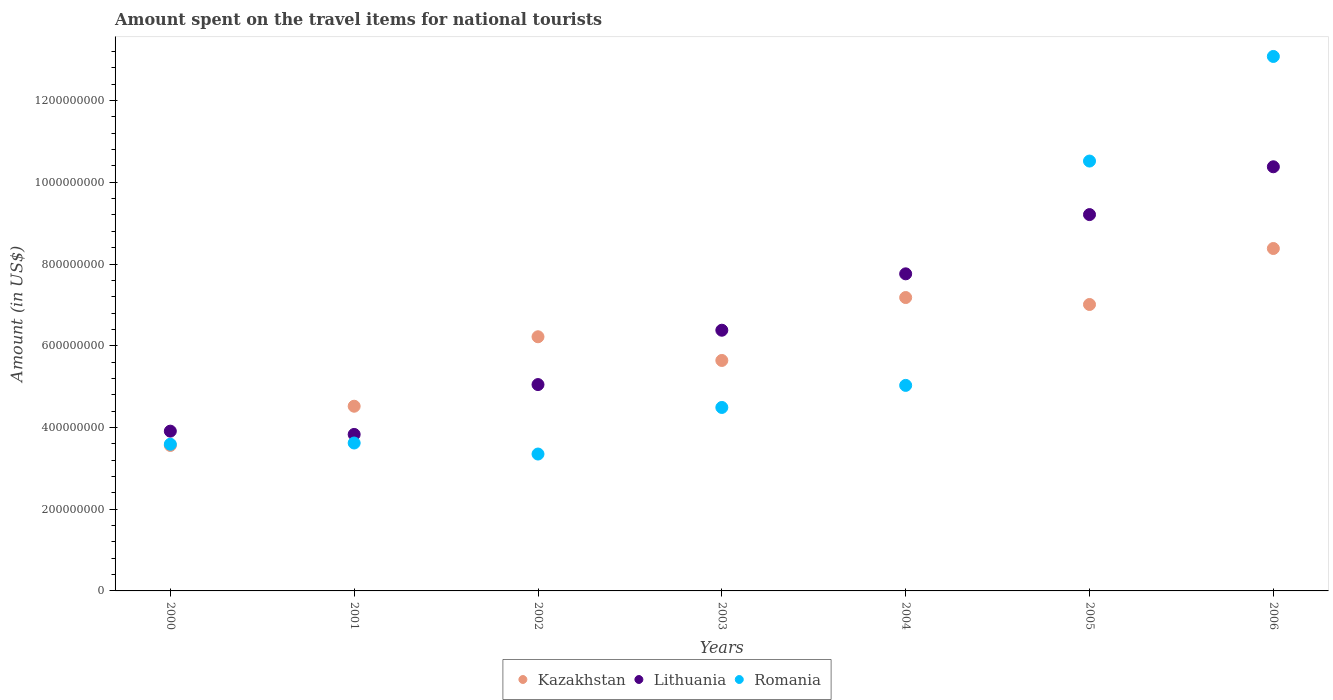How many different coloured dotlines are there?
Ensure brevity in your answer.  3. Is the number of dotlines equal to the number of legend labels?
Keep it short and to the point. Yes. What is the amount spent on the travel items for national tourists in Romania in 2001?
Keep it short and to the point. 3.62e+08. Across all years, what is the maximum amount spent on the travel items for national tourists in Kazakhstan?
Provide a short and direct response. 8.38e+08. Across all years, what is the minimum amount spent on the travel items for national tourists in Romania?
Ensure brevity in your answer.  3.35e+08. In which year was the amount spent on the travel items for national tourists in Lithuania maximum?
Provide a short and direct response. 2006. In which year was the amount spent on the travel items for national tourists in Kazakhstan minimum?
Provide a succinct answer. 2000. What is the total amount spent on the travel items for national tourists in Romania in the graph?
Give a very brief answer. 4.37e+09. What is the difference between the amount spent on the travel items for national tourists in Romania in 2000 and that in 2005?
Your response must be concise. -6.93e+08. What is the difference between the amount spent on the travel items for national tourists in Kazakhstan in 2000 and the amount spent on the travel items for national tourists in Romania in 2005?
Ensure brevity in your answer.  -6.96e+08. What is the average amount spent on the travel items for national tourists in Lithuania per year?
Keep it short and to the point. 6.65e+08. In the year 2003, what is the difference between the amount spent on the travel items for national tourists in Kazakhstan and amount spent on the travel items for national tourists in Lithuania?
Offer a very short reply. -7.40e+07. In how many years, is the amount spent on the travel items for national tourists in Kazakhstan greater than 960000000 US$?
Make the answer very short. 0. What is the ratio of the amount spent on the travel items for national tourists in Lithuania in 2004 to that in 2005?
Provide a succinct answer. 0.84. Is the difference between the amount spent on the travel items for national tourists in Kazakhstan in 2002 and 2004 greater than the difference between the amount spent on the travel items for national tourists in Lithuania in 2002 and 2004?
Your answer should be compact. Yes. What is the difference between the highest and the second highest amount spent on the travel items for national tourists in Kazakhstan?
Ensure brevity in your answer.  1.20e+08. What is the difference between the highest and the lowest amount spent on the travel items for national tourists in Romania?
Your answer should be compact. 9.73e+08. In how many years, is the amount spent on the travel items for national tourists in Romania greater than the average amount spent on the travel items for national tourists in Romania taken over all years?
Provide a succinct answer. 2. Is it the case that in every year, the sum of the amount spent on the travel items for national tourists in Romania and amount spent on the travel items for national tourists in Kazakhstan  is greater than the amount spent on the travel items for national tourists in Lithuania?
Offer a very short reply. Yes. Does the amount spent on the travel items for national tourists in Romania monotonically increase over the years?
Your answer should be very brief. No. How many dotlines are there?
Make the answer very short. 3. Where does the legend appear in the graph?
Ensure brevity in your answer.  Bottom center. What is the title of the graph?
Keep it short and to the point. Amount spent on the travel items for national tourists. What is the label or title of the Y-axis?
Your answer should be compact. Amount (in US$). What is the Amount (in US$) of Kazakhstan in 2000?
Make the answer very short. 3.56e+08. What is the Amount (in US$) in Lithuania in 2000?
Your answer should be very brief. 3.91e+08. What is the Amount (in US$) in Romania in 2000?
Ensure brevity in your answer.  3.59e+08. What is the Amount (in US$) of Kazakhstan in 2001?
Your answer should be very brief. 4.52e+08. What is the Amount (in US$) of Lithuania in 2001?
Make the answer very short. 3.83e+08. What is the Amount (in US$) in Romania in 2001?
Offer a terse response. 3.62e+08. What is the Amount (in US$) in Kazakhstan in 2002?
Your answer should be compact. 6.22e+08. What is the Amount (in US$) in Lithuania in 2002?
Your answer should be compact. 5.05e+08. What is the Amount (in US$) in Romania in 2002?
Offer a terse response. 3.35e+08. What is the Amount (in US$) of Kazakhstan in 2003?
Offer a very short reply. 5.64e+08. What is the Amount (in US$) of Lithuania in 2003?
Your response must be concise. 6.38e+08. What is the Amount (in US$) in Romania in 2003?
Make the answer very short. 4.49e+08. What is the Amount (in US$) in Kazakhstan in 2004?
Keep it short and to the point. 7.18e+08. What is the Amount (in US$) in Lithuania in 2004?
Ensure brevity in your answer.  7.76e+08. What is the Amount (in US$) in Romania in 2004?
Provide a short and direct response. 5.03e+08. What is the Amount (in US$) of Kazakhstan in 2005?
Your answer should be compact. 7.01e+08. What is the Amount (in US$) of Lithuania in 2005?
Offer a terse response. 9.21e+08. What is the Amount (in US$) of Romania in 2005?
Ensure brevity in your answer.  1.05e+09. What is the Amount (in US$) in Kazakhstan in 2006?
Ensure brevity in your answer.  8.38e+08. What is the Amount (in US$) of Lithuania in 2006?
Offer a very short reply. 1.04e+09. What is the Amount (in US$) of Romania in 2006?
Make the answer very short. 1.31e+09. Across all years, what is the maximum Amount (in US$) of Kazakhstan?
Your answer should be compact. 8.38e+08. Across all years, what is the maximum Amount (in US$) in Lithuania?
Make the answer very short. 1.04e+09. Across all years, what is the maximum Amount (in US$) of Romania?
Provide a succinct answer. 1.31e+09. Across all years, what is the minimum Amount (in US$) in Kazakhstan?
Offer a very short reply. 3.56e+08. Across all years, what is the minimum Amount (in US$) in Lithuania?
Keep it short and to the point. 3.83e+08. Across all years, what is the minimum Amount (in US$) in Romania?
Your answer should be compact. 3.35e+08. What is the total Amount (in US$) of Kazakhstan in the graph?
Your answer should be compact. 4.25e+09. What is the total Amount (in US$) in Lithuania in the graph?
Your response must be concise. 4.65e+09. What is the total Amount (in US$) in Romania in the graph?
Ensure brevity in your answer.  4.37e+09. What is the difference between the Amount (in US$) in Kazakhstan in 2000 and that in 2001?
Make the answer very short. -9.60e+07. What is the difference between the Amount (in US$) in Kazakhstan in 2000 and that in 2002?
Provide a succinct answer. -2.66e+08. What is the difference between the Amount (in US$) in Lithuania in 2000 and that in 2002?
Ensure brevity in your answer.  -1.14e+08. What is the difference between the Amount (in US$) of Romania in 2000 and that in 2002?
Your answer should be compact. 2.40e+07. What is the difference between the Amount (in US$) of Kazakhstan in 2000 and that in 2003?
Keep it short and to the point. -2.08e+08. What is the difference between the Amount (in US$) of Lithuania in 2000 and that in 2003?
Provide a succinct answer. -2.47e+08. What is the difference between the Amount (in US$) in Romania in 2000 and that in 2003?
Offer a terse response. -9.00e+07. What is the difference between the Amount (in US$) in Kazakhstan in 2000 and that in 2004?
Offer a terse response. -3.62e+08. What is the difference between the Amount (in US$) of Lithuania in 2000 and that in 2004?
Make the answer very short. -3.85e+08. What is the difference between the Amount (in US$) of Romania in 2000 and that in 2004?
Provide a succinct answer. -1.44e+08. What is the difference between the Amount (in US$) of Kazakhstan in 2000 and that in 2005?
Make the answer very short. -3.45e+08. What is the difference between the Amount (in US$) in Lithuania in 2000 and that in 2005?
Your answer should be very brief. -5.30e+08. What is the difference between the Amount (in US$) of Romania in 2000 and that in 2005?
Your answer should be very brief. -6.93e+08. What is the difference between the Amount (in US$) of Kazakhstan in 2000 and that in 2006?
Ensure brevity in your answer.  -4.82e+08. What is the difference between the Amount (in US$) in Lithuania in 2000 and that in 2006?
Offer a very short reply. -6.47e+08. What is the difference between the Amount (in US$) of Romania in 2000 and that in 2006?
Your response must be concise. -9.49e+08. What is the difference between the Amount (in US$) of Kazakhstan in 2001 and that in 2002?
Keep it short and to the point. -1.70e+08. What is the difference between the Amount (in US$) of Lithuania in 2001 and that in 2002?
Make the answer very short. -1.22e+08. What is the difference between the Amount (in US$) in Romania in 2001 and that in 2002?
Make the answer very short. 2.70e+07. What is the difference between the Amount (in US$) of Kazakhstan in 2001 and that in 2003?
Offer a very short reply. -1.12e+08. What is the difference between the Amount (in US$) of Lithuania in 2001 and that in 2003?
Provide a succinct answer. -2.55e+08. What is the difference between the Amount (in US$) in Romania in 2001 and that in 2003?
Your answer should be compact. -8.70e+07. What is the difference between the Amount (in US$) of Kazakhstan in 2001 and that in 2004?
Offer a very short reply. -2.66e+08. What is the difference between the Amount (in US$) in Lithuania in 2001 and that in 2004?
Give a very brief answer. -3.93e+08. What is the difference between the Amount (in US$) in Romania in 2001 and that in 2004?
Make the answer very short. -1.41e+08. What is the difference between the Amount (in US$) in Kazakhstan in 2001 and that in 2005?
Make the answer very short. -2.49e+08. What is the difference between the Amount (in US$) in Lithuania in 2001 and that in 2005?
Provide a short and direct response. -5.38e+08. What is the difference between the Amount (in US$) in Romania in 2001 and that in 2005?
Give a very brief answer. -6.90e+08. What is the difference between the Amount (in US$) in Kazakhstan in 2001 and that in 2006?
Your answer should be very brief. -3.86e+08. What is the difference between the Amount (in US$) in Lithuania in 2001 and that in 2006?
Keep it short and to the point. -6.55e+08. What is the difference between the Amount (in US$) in Romania in 2001 and that in 2006?
Your answer should be compact. -9.46e+08. What is the difference between the Amount (in US$) of Kazakhstan in 2002 and that in 2003?
Ensure brevity in your answer.  5.80e+07. What is the difference between the Amount (in US$) of Lithuania in 2002 and that in 2003?
Your response must be concise. -1.33e+08. What is the difference between the Amount (in US$) of Romania in 2002 and that in 2003?
Your answer should be compact. -1.14e+08. What is the difference between the Amount (in US$) in Kazakhstan in 2002 and that in 2004?
Make the answer very short. -9.60e+07. What is the difference between the Amount (in US$) of Lithuania in 2002 and that in 2004?
Ensure brevity in your answer.  -2.71e+08. What is the difference between the Amount (in US$) in Romania in 2002 and that in 2004?
Provide a short and direct response. -1.68e+08. What is the difference between the Amount (in US$) in Kazakhstan in 2002 and that in 2005?
Your answer should be compact. -7.90e+07. What is the difference between the Amount (in US$) of Lithuania in 2002 and that in 2005?
Provide a succinct answer. -4.16e+08. What is the difference between the Amount (in US$) in Romania in 2002 and that in 2005?
Keep it short and to the point. -7.17e+08. What is the difference between the Amount (in US$) in Kazakhstan in 2002 and that in 2006?
Your response must be concise. -2.16e+08. What is the difference between the Amount (in US$) in Lithuania in 2002 and that in 2006?
Make the answer very short. -5.33e+08. What is the difference between the Amount (in US$) of Romania in 2002 and that in 2006?
Offer a terse response. -9.73e+08. What is the difference between the Amount (in US$) in Kazakhstan in 2003 and that in 2004?
Offer a terse response. -1.54e+08. What is the difference between the Amount (in US$) in Lithuania in 2003 and that in 2004?
Give a very brief answer. -1.38e+08. What is the difference between the Amount (in US$) of Romania in 2003 and that in 2004?
Provide a succinct answer. -5.40e+07. What is the difference between the Amount (in US$) of Kazakhstan in 2003 and that in 2005?
Your response must be concise. -1.37e+08. What is the difference between the Amount (in US$) in Lithuania in 2003 and that in 2005?
Your answer should be very brief. -2.83e+08. What is the difference between the Amount (in US$) in Romania in 2003 and that in 2005?
Offer a terse response. -6.03e+08. What is the difference between the Amount (in US$) of Kazakhstan in 2003 and that in 2006?
Provide a short and direct response. -2.74e+08. What is the difference between the Amount (in US$) in Lithuania in 2003 and that in 2006?
Offer a terse response. -4.00e+08. What is the difference between the Amount (in US$) in Romania in 2003 and that in 2006?
Provide a succinct answer. -8.59e+08. What is the difference between the Amount (in US$) in Kazakhstan in 2004 and that in 2005?
Your answer should be very brief. 1.70e+07. What is the difference between the Amount (in US$) of Lithuania in 2004 and that in 2005?
Provide a succinct answer. -1.45e+08. What is the difference between the Amount (in US$) in Romania in 2004 and that in 2005?
Your answer should be compact. -5.49e+08. What is the difference between the Amount (in US$) in Kazakhstan in 2004 and that in 2006?
Your response must be concise. -1.20e+08. What is the difference between the Amount (in US$) in Lithuania in 2004 and that in 2006?
Give a very brief answer. -2.62e+08. What is the difference between the Amount (in US$) of Romania in 2004 and that in 2006?
Make the answer very short. -8.05e+08. What is the difference between the Amount (in US$) in Kazakhstan in 2005 and that in 2006?
Give a very brief answer. -1.37e+08. What is the difference between the Amount (in US$) in Lithuania in 2005 and that in 2006?
Your answer should be compact. -1.17e+08. What is the difference between the Amount (in US$) of Romania in 2005 and that in 2006?
Provide a short and direct response. -2.56e+08. What is the difference between the Amount (in US$) in Kazakhstan in 2000 and the Amount (in US$) in Lithuania in 2001?
Offer a terse response. -2.70e+07. What is the difference between the Amount (in US$) in Kazakhstan in 2000 and the Amount (in US$) in Romania in 2001?
Offer a terse response. -6.00e+06. What is the difference between the Amount (in US$) of Lithuania in 2000 and the Amount (in US$) of Romania in 2001?
Ensure brevity in your answer.  2.90e+07. What is the difference between the Amount (in US$) of Kazakhstan in 2000 and the Amount (in US$) of Lithuania in 2002?
Offer a terse response. -1.49e+08. What is the difference between the Amount (in US$) of Kazakhstan in 2000 and the Amount (in US$) of Romania in 2002?
Your response must be concise. 2.10e+07. What is the difference between the Amount (in US$) in Lithuania in 2000 and the Amount (in US$) in Romania in 2002?
Your response must be concise. 5.60e+07. What is the difference between the Amount (in US$) of Kazakhstan in 2000 and the Amount (in US$) of Lithuania in 2003?
Make the answer very short. -2.82e+08. What is the difference between the Amount (in US$) in Kazakhstan in 2000 and the Amount (in US$) in Romania in 2003?
Your answer should be very brief. -9.30e+07. What is the difference between the Amount (in US$) in Lithuania in 2000 and the Amount (in US$) in Romania in 2003?
Your answer should be very brief. -5.80e+07. What is the difference between the Amount (in US$) of Kazakhstan in 2000 and the Amount (in US$) of Lithuania in 2004?
Provide a succinct answer. -4.20e+08. What is the difference between the Amount (in US$) of Kazakhstan in 2000 and the Amount (in US$) of Romania in 2004?
Your response must be concise. -1.47e+08. What is the difference between the Amount (in US$) in Lithuania in 2000 and the Amount (in US$) in Romania in 2004?
Provide a succinct answer. -1.12e+08. What is the difference between the Amount (in US$) in Kazakhstan in 2000 and the Amount (in US$) in Lithuania in 2005?
Keep it short and to the point. -5.65e+08. What is the difference between the Amount (in US$) in Kazakhstan in 2000 and the Amount (in US$) in Romania in 2005?
Provide a succinct answer. -6.96e+08. What is the difference between the Amount (in US$) of Lithuania in 2000 and the Amount (in US$) of Romania in 2005?
Give a very brief answer. -6.61e+08. What is the difference between the Amount (in US$) of Kazakhstan in 2000 and the Amount (in US$) of Lithuania in 2006?
Your answer should be compact. -6.82e+08. What is the difference between the Amount (in US$) in Kazakhstan in 2000 and the Amount (in US$) in Romania in 2006?
Your answer should be very brief. -9.52e+08. What is the difference between the Amount (in US$) in Lithuania in 2000 and the Amount (in US$) in Romania in 2006?
Offer a terse response. -9.17e+08. What is the difference between the Amount (in US$) in Kazakhstan in 2001 and the Amount (in US$) in Lithuania in 2002?
Make the answer very short. -5.30e+07. What is the difference between the Amount (in US$) in Kazakhstan in 2001 and the Amount (in US$) in Romania in 2002?
Provide a succinct answer. 1.17e+08. What is the difference between the Amount (in US$) of Lithuania in 2001 and the Amount (in US$) of Romania in 2002?
Make the answer very short. 4.80e+07. What is the difference between the Amount (in US$) of Kazakhstan in 2001 and the Amount (in US$) of Lithuania in 2003?
Provide a succinct answer. -1.86e+08. What is the difference between the Amount (in US$) of Lithuania in 2001 and the Amount (in US$) of Romania in 2003?
Provide a short and direct response. -6.60e+07. What is the difference between the Amount (in US$) in Kazakhstan in 2001 and the Amount (in US$) in Lithuania in 2004?
Keep it short and to the point. -3.24e+08. What is the difference between the Amount (in US$) of Kazakhstan in 2001 and the Amount (in US$) of Romania in 2004?
Keep it short and to the point. -5.10e+07. What is the difference between the Amount (in US$) in Lithuania in 2001 and the Amount (in US$) in Romania in 2004?
Keep it short and to the point. -1.20e+08. What is the difference between the Amount (in US$) in Kazakhstan in 2001 and the Amount (in US$) in Lithuania in 2005?
Provide a short and direct response. -4.69e+08. What is the difference between the Amount (in US$) in Kazakhstan in 2001 and the Amount (in US$) in Romania in 2005?
Offer a terse response. -6.00e+08. What is the difference between the Amount (in US$) in Lithuania in 2001 and the Amount (in US$) in Romania in 2005?
Your answer should be very brief. -6.69e+08. What is the difference between the Amount (in US$) in Kazakhstan in 2001 and the Amount (in US$) in Lithuania in 2006?
Provide a succinct answer. -5.86e+08. What is the difference between the Amount (in US$) in Kazakhstan in 2001 and the Amount (in US$) in Romania in 2006?
Keep it short and to the point. -8.56e+08. What is the difference between the Amount (in US$) in Lithuania in 2001 and the Amount (in US$) in Romania in 2006?
Offer a terse response. -9.25e+08. What is the difference between the Amount (in US$) of Kazakhstan in 2002 and the Amount (in US$) of Lithuania in 2003?
Ensure brevity in your answer.  -1.60e+07. What is the difference between the Amount (in US$) of Kazakhstan in 2002 and the Amount (in US$) of Romania in 2003?
Make the answer very short. 1.73e+08. What is the difference between the Amount (in US$) of Lithuania in 2002 and the Amount (in US$) of Romania in 2003?
Give a very brief answer. 5.60e+07. What is the difference between the Amount (in US$) of Kazakhstan in 2002 and the Amount (in US$) of Lithuania in 2004?
Provide a short and direct response. -1.54e+08. What is the difference between the Amount (in US$) in Kazakhstan in 2002 and the Amount (in US$) in Romania in 2004?
Your answer should be very brief. 1.19e+08. What is the difference between the Amount (in US$) of Lithuania in 2002 and the Amount (in US$) of Romania in 2004?
Your response must be concise. 2.00e+06. What is the difference between the Amount (in US$) of Kazakhstan in 2002 and the Amount (in US$) of Lithuania in 2005?
Your response must be concise. -2.99e+08. What is the difference between the Amount (in US$) of Kazakhstan in 2002 and the Amount (in US$) of Romania in 2005?
Make the answer very short. -4.30e+08. What is the difference between the Amount (in US$) in Lithuania in 2002 and the Amount (in US$) in Romania in 2005?
Ensure brevity in your answer.  -5.47e+08. What is the difference between the Amount (in US$) in Kazakhstan in 2002 and the Amount (in US$) in Lithuania in 2006?
Keep it short and to the point. -4.16e+08. What is the difference between the Amount (in US$) in Kazakhstan in 2002 and the Amount (in US$) in Romania in 2006?
Make the answer very short. -6.86e+08. What is the difference between the Amount (in US$) of Lithuania in 2002 and the Amount (in US$) of Romania in 2006?
Ensure brevity in your answer.  -8.03e+08. What is the difference between the Amount (in US$) in Kazakhstan in 2003 and the Amount (in US$) in Lithuania in 2004?
Offer a very short reply. -2.12e+08. What is the difference between the Amount (in US$) of Kazakhstan in 2003 and the Amount (in US$) of Romania in 2004?
Ensure brevity in your answer.  6.10e+07. What is the difference between the Amount (in US$) of Lithuania in 2003 and the Amount (in US$) of Romania in 2004?
Make the answer very short. 1.35e+08. What is the difference between the Amount (in US$) in Kazakhstan in 2003 and the Amount (in US$) in Lithuania in 2005?
Your answer should be compact. -3.57e+08. What is the difference between the Amount (in US$) of Kazakhstan in 2003 and the Amount (in US$) of Romania in 2005?
Provide a succinct answer. -4.88e+08. What is the difference between the Amount (in US$) of Lithuania in 2003 and the Amount (in US$) of Romania in 2005?
Offer a terse response. -4.14e+08. What is the difference between the Amount (in US$) in Kazakhstan in 2003 and the Amount (in US$) in Lithuania in 2006?
Your answer should be very brief. -4.74e+08. What is the difference between the Amount (in US$) of Kazakhstan in 2003 and the Amount (in US$) of Romania in 2006?
Your answer should be very brief. -7.44e+08. What is the difference between the Amount (in US$) in Lithuania in 2003 and the Amount (in US$) in Romania in 2006?
Offer a very short reply. -6.70e+08. What is the difference between the Amount (in US$) of Kazakhstan in 2004 and the Amount (in US$) of Lithuania in 2005?
Give a very brief answer. -2.03e+08. What is the difference between the Amount (in US$) of Kazakhstan in 2004 and the Amount (in US$) of Romania in 2005?
Offer a very short reply. -3.34e+08. What is the difference between the Amount (in US$) of Lithuania in 2004 and the Amount (in US$) of Romania in 2005?
Ensure brevity in your answer.  -2.76e+08. What is the difference between the Amount (in US$) of Kazakhstan in 2004 and the Amount (in US$) of Lithuania in 2006?
Your response must be concise. -3.20e+08. What is the difference between the Amount (in US$) of Kazakhstan in 2004 and the Amount (in US$) of Romania in 2006?
Keep it short and to the point. -5.90e+08. What is the difference between the Amount (in US$) of Lithuania in 2004 and the Amount (in US$) of Romania in 2006?
Give a very brief answer. -5.32e+08. What is the difference between the Amount (in US$) in Kazakhstan in 2005 and the Amount (in US$) in Lithuania in 2006?
Offer a terse response. -3.37e+08. What is the difference between the Amount (in US$) in Kazakhstan in 2005 and the Amount (in US$) in Romania in 2006?
Offer a terse response. -6.07e+08. What is the difference between the Amount (in US$) of Lithuania in 2005 and the Amount (in US$) of Romania in 2006?
Give a very brief answer. -3.87e+08. What is the average Amount (in US$) of Kazakhstan per year?
Keep it short and to the point. 6.07e+08. What is the average Amount (in US$) of Lithuania per year?
Offer a terse response. 6.65e+08. What is the average Amount (in US$) of Romania per year?
Your answer should be compact. 6.24e+08. In the year 2000, what is the difference between the Amount (in US$) of Kazakhstan and Amount (in US$) of Lithuania?
Make the answer very short. -3.50e+07. In the year 2000, what is the difference between the Amount (in US$) in Lithuania and Amount (in US$) in Romania?
Keep it short and to the point. 3.20e+07. In the year 2001, what is the difference between the Amount (in US$) in Kazakhstan and Amount (in US$) in Lithuania?
Your answer should be very brief. 6.90e+07. In the year 2001, what is the difference between the Amount (in US$) in Kazakhstan and Amount (in US$) in Romania?
Offer a very short reply. 9.00e+07. In the year 2001, what is the difference between the Amount (in US$) of Lithuania and Amount (in US$) of Romania?
Give a very brief answer. 2.10e+07. In the year 2002, what is the difference between the Amount (in US$) in Kazakhstan and Amount (in US$) in Lithuania?
Provide a succinct answer. 1.17e+08. In the year 2002, what is the difference between the Amount (in US$) in Kazakhstan and Amount (in US$) in Romania?
Give a very brief answer. 2.87e+08. In the year 2002, what is the difference between the Amount (in US$) of Lithuania and Amount (in US$) of Romania?
Give a very brief answer. 1.70e+08. In the year 2003, what is the difference between the Amount (in US$) of Kazakhstan and Amount (in US$) of Lithuania?
Offer a terse response. -7.40e+07. In the year 2003, what is the difference between the Amount (in US$) of Kazakhstan and Amount (in US$) of Romania?
Offer a terse response. 1.15e+08. In the year 2003, what is the difference between the Amount (in US$) in Lithuania and Amount (in US$) in Romania?
Your response must be concise. 1.89e+08. In the year 2004, what is the difference between the Amount (in US$) in Kazakhstan and Amount (in US$) in Lithuania?
Your response must be concise. -5.80e+07. In the year 2004, what is the difference between the Amount (in US$) in Kazakhstan and Amount (in US$) in Romania?
Offer a terse response. 2.15e+08. In the year 2004, what is the difference between the Amount (in US$) of Lithuania and Amount (in US$) of Romania?
Your answer should be very brief. 2.73e+08. In the year 2005, what is the difference between the Amount (in US$) in Kazakhstan and Amount (in US$) in Lithuania?
Offer a terse response. -2.20e+08. In the year 2005, what is the difference between the Amount (in US$) of Kazakhstan and Amount (in US$) of Romania?
Offer a terse response. -3.51e+08. In the year 2005, what is the difference between the Amount (in US$) in Lithuania and Amount (in US$) in Romania?
Provide a succinct answer. -1.31e+08. In the year 2006, what is the difference between the Amount (in US$) of Kazakhstan and Amount (in US$) of Lithuania?
Offer a very short reply. -2.00e+08. In the year 2006, what is the difference between the Amount (in US$) in Kazakhstan and Amount (in US$) in Romania?
Give a very brief answer. -4.70e+08. In the year 2006, what is the difference between the Amount (in US$) of Lithuania and Amount (in US$) of Romania?
Provide a succinct answer. -2.70e+08. What is the ratio of the Amount (in US$) of Kazakhstan in 2000 to that in 2001?
Your answer should be compact. 0.79. What is the ratio of the Amount (in US$) of Lithuania in 2000 to that in 2001?
Your answer should be compact. 1.02. What is the ratio of the Amount (in US$) of Romania in 2000 to that in 2001?
Your response must be concise. 0.99. What is the ratio of the Amount (in US$) of Kazakhstan in 2000 to that in 2002?
Offer a very short reply. 0.57. What is the ratio of the Amount (in US$) of Lithuania in 2000 to that in 2002?
Offer a very short reply. 0.77. What is the ratio of the Amount (in US$) of Romania in 2000 to that in 2002?
Provide a succinct answer. 1.07. What is the ratio of the Amount (in US$) of Kazakhstan in 2000 to that in 2003?
Give a very brief answer. 0.63. What is the ratio of the Amount (in US$) of Lithuania in 2000 to that in 2003?
Ensure brevity in your answer.  0.61. What is the ratio of the Amount (in US$) of Romania in 2000 to that in 2003?
Provide a succinct answer. 0.8. What is the ratio of the Amount (in US$) in Kazakhstan in 2000 to that in 2004?
Ensure brevity in your answer.  0.5. What is the ratio of the Amount (in US$) in Lithuania in 2000 to that in 2004?
Make the answer very short. 0.5. What is the ratio of the Amount (in US$) of Romania in 2000 to that in 2004?
Your answer should be very brief. 0.71. What is the ratio of the Amount (in US$) in Kazakhstan in 2000 to that in 2005?
Your answer should be very brief. 0.51. What is the ratio of the Amount (in US$) of Lithuania in 2000 to that in 2005?
Provide a succinct answer. 0.42. What is the ratio of the Amount (in US$) of Romania in 2000 to that in 2005?
Make the answer very short. 0.34. What is the ratio of the Amount (in US$) of Kazakhstan in 2000 to that in 2006?
Your answer should be very brief. 0.42. What is the ratio of the Amount (in US$) of Lithuania in 2000 to that in 2006?
Provide a succinct answer. 0.38. What is the ratio of the Amount (in US$) in Romania in 2000 to that in 2006?
Offer a very short reply. 0.27. What is the ratio of the Amount (in US$) in Kazakhstan in 2001 to that in 2002?
Offer a terse response. 0.73. What is the ratio of the Amount (in US$) of Lithuania in 2001 to that in 2002?
Keep it short and to the point. 0.76. What is the ratio of the Amount (in US$) in Romania in 2001 to that in 2002?
Provide a short and direct response. 1.08. What is the ratio of the Amount (in US$) in Kazakhstan in 2001 to that in 2003?
Offer a very short reply. 0.8. What is the ratio of the Amount (in US$) in Lithuania in 2001 to that in 2003?
Make the answer very short. 0.6. What is the ratio of the Amount (in US$) of Romania in 2001 to that in 2003?
Your answer should be very brief. 0.81. What is the ratio of the Amount (in US$) in Kazakhstan in 2001 to that in 2004?
Provide a succinct answer. 0.63. What is the ratio of the Amount (in US$) in Lithuania in 2001 to that in 2004?
Provide a short and direct response. 0.49. What is the ratio of the Amount (in US$) of Romania in 2001 to that in 2004?
Provide a short and direct response. 0.72. What is the ratio of the Amount (in US$) in Kazakhstan in 2001 to that in 2005?
Provide a short and direct response. 0.64. What is the ratio of the Amount (in US$) in Lithuania in 2001 to that in 2005?
Your response must be concise. 0.42. What is the ratio of the Amount (in US$) of Romania in 2001 to that in 2005?
Provide a succinct answer. 0.34. What is the ratio of the Amount (in US$) in Kazakhstan in 2001 to that in 2006?
Ensure brevity in your answer.  0.54. What is the ratio of the Amount (in US$) in Lithuania in 2001 to that in 2006?
Keep it short and to the point. 0.37. What is the ratio of the Amount (in US$) in Romania in 2001 to that in 2006?
Provide a short and direct response. 0.28. What is the ratio of the Amount (in US$) of Kazakhstan in 2002 to that in 2003?
Make the answer very short. 1.1. What is the ratio of the Amount (in US$) of Lithuania in 2002 to that in 2003?
Ensure brevity in your answer.  0.79. What is the ratio of the Amount (in US$) in Romania in 2002 to that in 2003?
Ensure brevity in your answer.  0.75. What is the ratio of the Amount (in US$) in Kazakhstan in 2002 to that in 2004?
Ensure brevity in your answer.  0.87. What is the ratio of the Amount (in US$) in Lithuania in 2002 to that in 2004?
Your answer should be compact. 0.65. What is the ratio of the Amount (in US$) in Romania in 2002 to that in 2004?
Ensure brevity in your answer.  0.67. What is the ratio of the Amount (in US$) of Kazakhstan in 2002 to that in 2005?
Ensure brevity in your answer.  0.89. What is the ratio of the Amount (in US$) of Lithuania in 2002 to that in 2005?
Provide a short and direct response. 0.55. What is the ratio of the Amount (in US$) of Romania in 2002 to that in 2005?
Keep it short and to the point. 0.32. What is the ratio of the Amount (in US$) in Kazakhstan in 2002 to that in 2006?
Provide a succinct answer. 0.74. What is the ratio of the Amount (in US$) of Lithuania in 2002 to that in 2006?
Provide a short and direct response. 0.49. What is the ratio of the Amount (in US$) in Romania in 2002 to that in 2006?
Provide a short and direct response. 0.26. What is the ratio of the Amount (in US$) in Kazakhstan in 2003 to that in 2004?
Your answer should be very brief. 0.79. What is the ratio of the Amount (in US$) of Lithuania in 2003 to that in 2004?
Your answer should be compact. 0.82. What is the ratio of the Amount (in US$) of Romania in 2003 to that in 2004?
Your answer should be compact. 0.89. What is the ratio of the Amount (in US$) in Kazakhstan in 2003 to that in 2005?
Your response must be concise. 0.8. What is the ratio of the Amount (in US$) of Lithuania in 2003 to that in 2005?
Keep it short and to the point. 0.69. What is the ratio of the Amount (in US$) of Romania in 2003 to that in 2005?
Your response must be concise. 0.43. What is the ratio of the Amount (in US$) of Kazakhstan in 2003 to that in 2006?
Your response must be concise. 0.67. What is the ratio of the Amount (in US$) of Lithuania in 2003 to that in 2006?
Make the answer very short. 0.61. What is the ratio of the Amount (in US$) in Romania in 2003 to that in 2006?
Provide a short and direct response. 0.34. What is the ratio of the Amount (in US$) in Kazakhstan in 2004 to that in 2005?
Your answer should be very brief. 1.02. What is the ratio of the Amount (in US$) in Lithuania in 2004 to that in 2005?
Your answer should be very brief. 0.84. What is the ratio of the Amount (in US$) of Romania in 2004 to that in 2005?
Provide a succinct answer. 0.48. What is the ratio of the Amount (in US$) in Kazakhstan in 2004 to that in 2006?
Your answer should be compact. 0.86. What is the ratio of the Amount (in US$) of Lithuania in 2004 to that in 2006?
Your answer should be compact. 0.75. What is the ratio of the Amount (in US$) in Romania in 2004 to that in 2006?
Make the answer very short. 0.38. What is the ratio of the Amount (in US$) of Kazakhstan in 2005 to that in 2006?
Offer a terse response. 0.84. What is the ratio of the Amount (in US$) in Lithuania in 2005 to that in 2006?
Give a very brief answer. 0.89. What is the ratio of the Amount (in US$) in Romania in 2005 to that in 2006?
Give a very brief answer. 0.8. What is the difference between the highest and the second highest Amount (in US$) of Kazakhstan?
Offer a very short reply. 1.20e+08. What is the difference between the highest and the second highest Amount (in US$) in Lithuania?
Offer a very short reply. 1.17e+08. What is the difference between the highest and the second highest Amount (in US$) of Romania?
Provide a succinct answer. 2.56e+08. What is the difference between the highest and the lowest Amount (in US$) in Kazakhstan?
Keep it short and to the point. 4.82e+08. What is the difference between the highest and the lowest Amount (in US$) in Lithuania?
Your answer should be very brief. 6.55e+08. What is the difference between the highest and the lowest Amount (in US$) of Romania?
Offer a very short reply. 9.73e+08. 